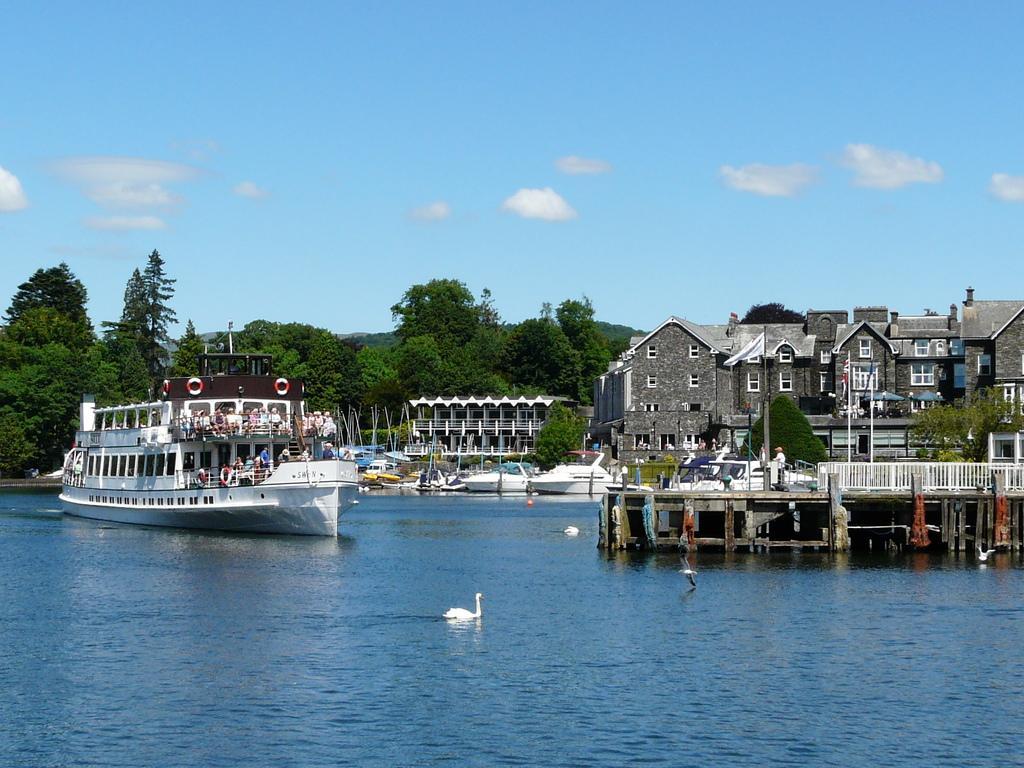Describe this image in one or two sentences. In this image we can see sky with clouds, trees, hills, ships, iron grill, buildings, flag, flag post, swans on the water and lake. 